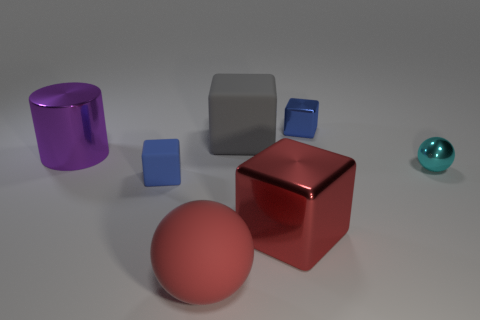Add 3 green balls. How many objects exist? 10 Subtract all spheres. How many objects are left? 5 Add 3 blue objects. How many blue objects exist? 5 Subtract 0 yellow spheres. How many objects are left? 7 Subtract all tiny blue cylinders. Subtract all metallic cylinders. How many objects are left? 6 Add 2 blue metallic objects. How many blue metallic objects are left? 3 